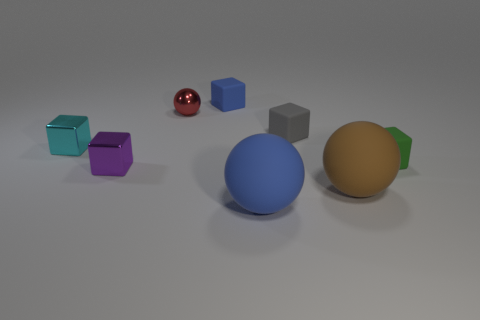There is a gray matte cube on the right side of the tiny cyan object; what is its size?
Your answer should be very brief. Small. Does the cyan cube have the same material as the blue ball?
Give a very brief answer. No. There is a small thing that is behind the metal object that is on the right side of the purple metallic cube; is there a large brown ball behind it?
Offer a terse response. No. The metallic ball has what color?
Your answer should be very brief. Red. The object that is the same size as the brown sphere is what color?
Keep it short and to the point. Blue. There is a blue object that is behind the small purple metallic block; is its shape the same as the gray rubber thing?
Offer a terse response. Yes. There is a metal cube that is in front of the tiny matte cube right of the big rubber thing to the right of the large blue rubber thing; what color is it?
Provide a succinct answer. Purple. Are any brown objects visible?
Offer a very short reply. Yes. What number of other objects are there of the same size as the purple cube?
Offer a terse response. 5. There is a tiny ball; does it have the same color as the small shiny block that is to the left of the purple cube?
Offer a very short reply. No. 